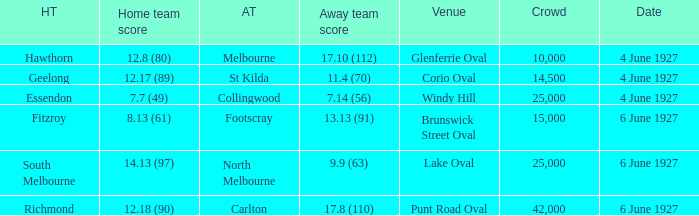Which venue's home team is geelong? Corio Oval. 